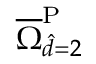Convert formula to latex. <formula><loc_0><loc_0><loc_500><loc_500>\overline { \Omega } _ { \hat { d } = 2 } ^ { P }</formula> 